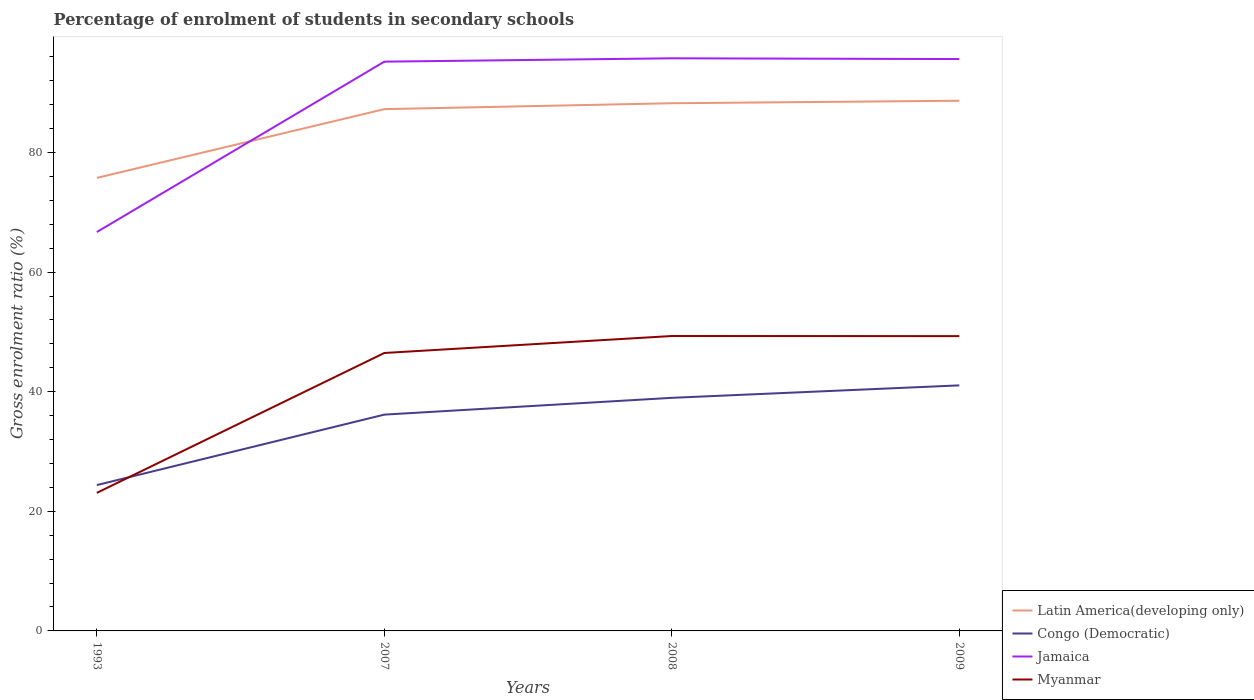How many different coloured lines are there?
Offer a terse response. 4. Does the line corresponding to Latin America(developing only) intersect with the line corresponding to Jamaica?
Offer a very short reply. Yes. Is the number of lines equal to the number of legend labels?
Keep it short and to the point. Yes. Across all years, what is the maximum percentage of students enrolled in secondary schools in Myanmar?
Offer a terse response. 23.09. What is the total percentage of students enrolled in secondary schools in Myanmar in the graph?
Ensure brevity in your answer.  -26.21. What is the difference between the highest and the second highest percentage of students enrolled in secondary schools in Jamaica?
Provide a short and direct response. 29.05. How many years are there in the graph?
Give a very brief answer. 4. Are the values on the major ticks of Y-axis written in scientific E-notation?
Your answer should be very brief. No. Does the graph contain any zero values?
Your answer should be very brief. No. Where does the legend appear in the graph?
Keep it short and to the point. Bottom right. What is the title of the graph?
Provide a succinct answer. Percentage of enrolment of students in secondary schools. What is the label or title of the Y-axis?
Ensure brevity in your answer.  Gross enrolment ratio (%). What is the Gross enrolment ratio (%) in Latin America(developing only) in 1993?
Provide a short and direct response. 75.75. What is the Gross enrolment ratio (%) of Congo (Democratic) in 1993?
Your answer should be very brief. 24.39. What is the Gross enrolment ratio (%) of Jamaica in 1993?
Give a very brief answer. 66.69. What is the Gross enrolment ratio (%) in Myanmar in 1993?
Your answer should be very brief. 23.09. What is the Gross enrolment ratio (%) of Latin America(developing only) in 2007?
Ensure brevity in your answer.  87.24. What is the Gross enrolment ratio (%) in Congo (Democratic) in 2007?
Offer a very short reply. 36.17. What is the Gross enrolment ratio (%) of Jamaica in 2007?
Provide a short and direct response. 95.18. What is the Gross enrolment ratio (%) of Myanmar in 2007?
Provide a short and direct response. 46.47. What is the Gross enrolment ratio (%) in Latin America(developing only) in 2008?
Your response must be concise. 88.23. What is the Gross enrolment ratio (%) in Congo (Democratic) in 2008?
Your response must be concise. 38.97. What is the Gross enrolment ratio (%) of Jamaica in 2008?
Your answer should be compact. 95.75. What is the Gross enrolment ratio (%) in Myanmar in 2008?
Provide a short and direct response. 49.31. What is the Gross enrolment ratio (%) in Latin America(developing only) in 2009?
Give a very brief answer. 88.65. What is the Gross enrolment ratio (%) in Congo (Democratic) in 2009?
Your answer should be very brief. 41.06. What is the Gross enrolment ratio (%) in Jamaica in 2009?
Provide a short and direct response. 95.62. What is the Gross enrolment ratio (%) in Myanmar in 2009?
Your response must be concise. 49.29. Across all years, what is the maximum Gross enrolment ratio (%) of Latin America(developing only)?
Ensure brevity in your answer.  88.65. Across all years, what is the maximum Gross enrolment ratio (%) in Congo (Democratic)?
Provide a succinct answer. 41.06. Across all years, what is the maximum Gross enrolment ratio (%) in Jamaica?
Make the answer very short. 95.75. Across all years, what is the maximum Gross enrolment ratio (%) of Myanmar?
Make the answer very short. 49.31. Across all years, what is the minimum Gross enrolment ratio (%) of Latin America(developing only)?
Your answer should be compact. 75.75. Across all years, what is the minimum Gross enrolment ratio (%) of Congo (Democratic)?
Make the answer very short. 24.39. Across all years, what is the minimum Gross enrolment ratio (%) in Jamaica?
Your answer should be compact. 66.69. Across all years, what is the minimum Gross enrolment ratio (%) of Myanmar?
Offer a very short reply. 23.09. What is the total Gross enrolment ratio (%) in Latin America(developing only) in the graph?
Keep it short and to the point. 339.88. What is the total Gross enrolment ratio (%) of Congo (Democratic) in the graph?
Give a very brief answer. 140.59. What is the total Gross enrolment ratio (%) in Jamaica in the graph?
Offer a terse response. 353.24. What is the total Gross enrolment ratio (%) in Myanmar in the graph?
Make the answer very short. 168.16. What is the difference between the Gross enrolment ratio (%) of Latin America(developing only) in 1993 and that in 2007?
Provide a short and direct response. -11.49. What is the difference between the Gross enrolment ratio (%) in Congo (Democratic) in 1993 and that in 2007?
Give a very brief answer. -11.78. What is the difference between the Gross enrolment ratio (%) in Jamaica in 1993 and that in 2007?
Your answer should be compact. -28.49. What is the difference between the Gross enrolment ratio (%) in Myanmar in 1993 and that in 2007?
Make the answer very short. -23.39. What is the difference between the Gross enrolment ratio (%) of Latin America(developing only) in 1993 and that in 2008?
Offer a terse response. -12.48. What is the difference between the Gross enrolment ratio (%) in Congo (Democratic) in 1993 and that in 2008?
Offer a very short reply. -14.59. What is the difference between the Gross enrolment ratio (%) in Jamaica in 1993 and that in 2008?
Your response must be concise. -29.05. What is the difference between the Gross enrolment ratio (%) in Myanmar in 1993 and that in 2008?
Offer a terse response. -26.22. What is the difference between the Gross enrolment ratio (%) of Latin America(developing only) in 1993 and that in 2009?
Give a very brief answer. -12.9. What is the difference between the Gross enrolment ratio (%) of Congo (Democratic) in 1993 and that in 2009?
Provide a short and direct response. -16.67. What is the difference between the Gross enrolment ratio (%) in Jamaica in 1993 and that in 2009?
Make the answer very short. -28.92. What is the difference between the Gross enrolment ratio (%) of Myanmar in 1993 and that in 2009?
Provide a succinct answer. -26.21. What is the difference between the Gross enrolment ratio (%) of Latin America(developing only) in 2007 and that in 2008?
Offer a very short reply. -0.99. What is the difference between the Gross enrolment ratio (%) in Congo (Democratic) in 2007 and that in 2008?
Keep it short and to the point. -2.81. What is the difference between the Gross enrolment ratio (%) of Jamaica in 2007 and that in 2008?
Your answer should be very brief. -0.56. What is the difference between the Gross enrolment ratio (%) of Myanmar in 2007 and that in 2008?
Provide a succinct answer. -2.84. What is the difference between the Gross enrolment ratio (%) in Latin America(developing only) in 2007 and that in 2009?
Your answer should be compact. -1.4. What is the difference between the Gross enrolment ratio (%) in Congo (Democratic) in 2007 and that in 2009?
Ensure brevity in your answer.  -4.89. What is the difference between the Gross enrolment ratio (%) of Jamaica in 2007 and that in 2009?
Your answer should be compact. -0.43. What is the difference between the Gross enrolment ratio (%) in Myanmar in 2007 and that in 2009?
Provide a succinct answer. -2.82. What is the difference between the Gross enrolment ratio (%) in Latin America(developing only) in 2008 and that in 2009?
Your answer should be compact. -0.42. What is the difference between the Gross enrolment ratio (%) in Congo (Democratic) in 2008 and that in 2009?
Offer a terse response. -2.08. What is the difference between the Gross enrolment ratio (%) of Jamaica in 2008 and that in 2009?
Make the answer very short. 0.13. What is the difference between the Gross enrolment ratio (%) of Myanmar in 2008 and that in 2009?
Keep it short and to the point. 0.02. What is the difference between the Gross enrolment ratio (%) of Latin America(developing only) in 1993 and the Gross enrolment ratio (%) of Congo (Democratic) in 2007?
Make the answer very short. 39.58. What is the difference between the Gross enrolment ratio (%) in Latin America(developing only) in 1993 and the Gross enrolment ratio (%) in Jamaica in 2007?
Offer a very short reply. -19.43. What is the difference between the Gross enrolment ratio (%) of Latin America(developing only) in 1993 and the Gross enrolment ratio (%) of Myanmar in 2007?
Make the answer very short. 29.28. What is the difference between the Gross enrolment ratio (%) in Congo (Democratic) in 1993 and the Gross enrolment ratio (%) in Jamaica in 2007?
Keep it short and to the point. -70.8. What is the difference between the Gross enrolment ratio (%) in Congo (Democratic) in 1993 and the Gross enrolment ratio (%) in Myanmar in 2007?
Provide a short and direct response. -22.09. What is the difference between the Gross enrolment ratio (%) of Jamaica in 1993 and the Gross enrolment ratio (%) of Myanmar in 2007?
Offer a very short reply. 20.22. What is the difference between the Gross enrolment ratio (%) in Latin America(developing only) in 1993 and the Gross enrolment ratio (%) in Congo (Democratic) in 2008?
Give a very brief answer. 36.78. What is the difference between the Gross enrolment ratio (%) in Latin America(developing only) in 1993 and the Gross enrolment ratio (%) in Jamaica in 2008?
Your answer should be compact. -19.99. What is the difference between the Gross enrolment ratio (%) of Latin America(developing only) in 1993 and the Gross enrolment ratio (%) of Myanmar in 2008?
Ensure brevity in your answer.  26.44. What is the difference between the Gross enrolment ratio (%) in Congo (Democratic) in 1993 and the Gross enrolment ratio (%) in Jamaica in 2008?
Keep it short and to the point. -71.36. What is the difference between the Gross enrolment ratio (%) of Congo (Democratic) in 1993 and the Gross enrolment ratio (%) of Myanmar in 2008?
Your answer should be compact. -24.92. What is the difference between the Gross enrolment ratio (%) of Jamaica in 1993 and the Gross enrolment ratio (%) of Myanmar in 2008?
Give a very brief answer. 17.38. What is the difference between the Gross enrolment ratio (%) of Latin America(developing only) in 1993 and the Gross enrolment ratio (%) of Congo (Democratic) in 2009?
Your response must be concise. 34.69. What is the difference between the Gross enrolment ratio (%) in Latin America(developing only) in 1993 and the Gross enrolment ratio (%) in Jamaica in 2009?
Ensure brevity in your answer.  -19.87. What is the difference between the Gross enrolment ratio (%) in Latin America(developing only) in 1993 and the Gross enrolment ratio (%) in Myanmar in 2009?
Your answer should be very brief. 26.46. What is the difference between the Gross enrolment ratio (%) in Congo (Democratic) in 1993 and the Gross enrolment ratio (%) in Jamaica in 2009?
Your answer should be compact. -71.23. What is the difference between the Gross enrolment ratio (%) in Congo (Democratic) in 1993 and the Gross enrolment ratio (%) in Myanmar in 2009?
Keep it short and to the point. -24.91. What is the difference between the Gross enrolment ratio (%) of Jamaica in 1993 and the Gross enrolment ratio (%) of Myanmar in 2009?
Make the answer very short. 17.4. What is the difference between the Gross enrolment ratio (%) of Latin America(developing only) in 2007 and the Gross enrolment ratio (%) of Congo (Democratic) in 2008?
Your response must be concise. 48.27. What is the difference between the Gross enrolment ratio (%) in Latin America(developing only) in 2007 and the Gross enrolment ratio (%) in Jamaica in 2008?
Offer a terse response. -8.5. What is the difference between the Gross enrolment ratio (%) in Latin America(developing only) in 2007 and the Gross enrolment ratio (%) in Myanmar in 2008?
Your response must be concise. 37.93. What is the difference between the Gross enrolment ratio (%) of Congo (Democratic) in 2007 and the Gross enrolment ratio (%) of Jamaica in 2008?
Keep it short and to the point. -59.58. What is the difference between the Gross enrolment ratio (%) of Congo (Democratic) in 2007 and the Gross enrolment ratio (%) of Myanmar in 2008?
Make the answer very short. -13.14. What is the difference between the Gross enrolment ratio (%) of Jamaica in 2007 and the Gross enrolment ratio (%) of Myanmar in 2008?
Offer a terse response. 45.87. What is the difference between the Gross enrolment ratio (%) in Latin America(developing only) in 2007 and the Gross enrolment ratio (%) in Congo (Democratic) in 2009?
Your answer should be compact. 46.19. What is the difference between the Gross enrolment ratio (%) of Latin America(developing only) in 2007 and the Gross enrolment ratio (%) of Jamaica in 2009?
Give a very brief answer. -8.37. What is the difference between the Gross enrolment ratio (%) of Latin America(developing only) in 2007 and the Gross enrolment ratio (%) of Myanmar in 2009?
Your answer should be very brief. 37.95. What is the difference between the Gross enrolment ratio (%) in Congo (Democratic) in 2007 and the Gross enrolment ratio (%) in Jamaica in 2009?
Ensure brevity in your answer.  -59.45. What is the difference between the Gross enrolment ratio (%) in Congo (Democratic) in 2007 and the Gross enrolment ratio (%) in Myanmar in 2009?
Ensure brevity in your answer.  -13.12. What is the difference between the Gross enrolment ratio (%) of Jamaica in 2007 and the Gross enrolment ratio (%) of Myanmar in 2009?
Offer a terse response. 45.89. What is the difference between the Gross enrolment ratio (%) of Latin America(developing only) in 2008 and the Gross enrolment ratio (%) of Congo (Democratic) in 2009?
Your answer should be compact. 47.17. What is the difference between the Gross enrolment ratio (%) in Latin America(developing only) in 2008 and the Gross enrolment ratio (%) in Jamaica in 2009?
Offer a very short reply. -7.39. What is the difference between the Gross enrolment ratio (%) in Latin America(developing only) in 2008 and the Gross enrolment ratio (%) in Myanmar in 2009?
Give a very brief answer. 38.94. What is the difference between the Gross enrolment ratio (%) of Congo (Democratic) in 2008 and the Gross enrolment ratio (%) of Jamaica in 2009?
Your answer should be compact. -56.65. What is the difference between the Gross enrolment ratio (%) of Congo (Democratic) in 2008 and the Gross enrolment ratio (%) of Myanmar in 2009?
Offer a very short reply. -10.32. What is the difference between the Gross enrolment ratio (%) in Jamaica in 2008 and the Gross enrolment ratio (%) in Myanmar in 2009?
Give a very brief answer. 46.45. What is the average Gross enrolment ratio (%) of Latin America(developing only) per year?
Make the answer very short. 84.97. What is the average Gross enrolment ratio (%) in Congo (Democratic) per year?
Keep it short and to the point. 35.15. What is the average Gross enrolment ratio (%) in Jamaica per year?
Provide a short and direct response. 88.31. What is the average Gross enrolment ratio (%) in Myanmar per year?
Offer a very short reply. 42.04. In the year 1993, what is the difference between the Gross enrolment ratio (%) in Latin America(developing only) and Gross enrolment ratio (%) in Congo (Democratic)?
Give a very brief answer. 51.36. In the year 1993, what is the difference between the Gross enrolment ratio (%) of Latin America(developing only) and Gross enrolment ratio (%) of Jamaica?
Give a very brief answer. 9.06. In the year 1993, what is the difference between the Gross enrolment ratio (%) in Latin America(developing only) and Gross enrolment ratio (%) in Myanmar?
Give a very brief answer. 52.66. In the year 1993, what is the difference between the Gross enrolment ratio (%) in Congo (Democratic) and Gross enrolment ratio (%) in Jamaica?
Provide a short and direct response. -42.31. In the year 1993, what is the difference between the Gross enrolment ratio (%) in Congo (Democratic) and Gross enrolment ratio (%) in Myanmar?
Keep it short and to the point. 1.3. In the year 1993, what is the difference between the Gross enrolment ratio (%) of Jamaica and Gross enrolment ratio (%) of Myanmar?
Ensure brevity in your answer.  43.61. In the year 2007, what is the difference between the Gross enrolment ratio (%) of Latin America(developing only) and Gross enrolment ratio (%) of Congo (Democratic)?
Provide a succinct answer. 51.08. In the year 2007, what is the difference between the Gross enrolment ratio (%) of Latin America(developing only) and Gross enrolment ratio (%) of Jamaica?
Keep it short and to the point. -7.94. In the year 2007, what is the difference between the Gross enrolment ratio (%) of Latin America(developing only) and Gross enrolment ratio (%) of Myanmar?
Your answer should be compact. 40.77. In the year 2007, what is the difference between the Gross enrolment ratio (%) of Congo (Democratic) and Gross enrolment ratio (%) of Jamaica?
Your response must be concise. -59.02. In the year 2007, what is the difference between the Gross enrolment ratio (%) of Congo (Democratic) and Gross enrolment ratio (%) of Myanmar?
Offer a very short reply. -10.31. In the year 2007, what is the difference between the Gross enrolment ratio (%) of Jamaica and Gross enrolment ratio (%) of Myanmar?
Your answer should be compact. 48.71. In the year 2008, what is the difference between the Gross enrolment ratio (%) in Latin America(developing only) and Gross enrolment ratio (%) in Congo (Democratic)?
Your answer should be compact. 49.26. In the year 2008, what is the difference between the Gross enrolment ratio (%) of Latin America(developing only) and Gross enrolment ratio (%) of Jamaica?
Make the answer very short. -7.51. In the year 2008, what is the difference between the Gross enrolment ratio (%) in Latin America(developing only) and Gross enrolment ratio (%) in Myanmar?
Keep it short and to the point. 38.92. In the year 2008, what is the difference between the Gross enrolment ratio (%) of Congo (Democratic) and Gross enrolment ratio (%) of Jamaica?
Keep it short and to the point. -56.77. In the year 2008, what is the difference between the Gross enrolment ratio (%) of Congo (Democratic) and Gross enrolment ratio (%) of Myanmar?
Offer a very short reply. -10.34. In the year 2008, what is the difference between the Gross enrolment ratio (%) of Jamaica and Gross enrolment ratio (%) of Myanmar?
Your answer should be compact. 46.44. In the year 2009, what is the difference between the Gross enrolment ratio (%) in Latin America(developing only) and Gross enrolment ratio (%) in Congo (Democratic)?
Offer a terse response. 47.59. In the year 2009, what is the difference between the Gross enrolment ratio (%) in Latin America(developing only) and Gross enrolment ratio (%) in Jamaica?
Your answer should be compact. -6.97. In the year 2009, what is the difference between the Gross enrolment ratio (%) in Latin America(developing only) and Gross enrolment ratio (%) in Myanmar?
Provide a succinct answer. 39.36. In the year 2009, what is the difference between the Gross enrolment ratio (%) in Congo (Democratic) and Gross enrolment ratio (%) in Jamaica?
Ensure brevity in your answer.  -54.56. In the year 2009, what is the difference between the Gross enrolment ratio (%) in Congo (Democratic) and Gross enrolment ratio (%) in Myanmar?
Your answer should be very brief. -8.23. In the year 2009, what is the difference between the Gross enrolment ratio (%) in Jamaica and Gross enrolment ratio (%) in Myanmar?
Your answer should be compact. 46.33. What is the ratio of the Gross enrolment ratio (%) of Latin America(developing only) in 1993 to that in 2007?
Provide a short and direct response. 0.87. What is the ratio of the Gross enrolment ratio (%) of Congo (Democratic) in 1993 to that in 2007?
Ensure brevity in your answer.  0.67. What is the ratio of the Gross enrolment ratio (%) in Jamaica in 1993 to that in 2007?
Your answer should be very brief. 0.7. What is the ratio of the Gross enrolment ratio (%) in Myanmar in 1993 to that in 2007?
Make the answer very short. 0.5. What is the ratio of the Gross enrolment ratio (%) in Latin America(developing only) in 1993 to that in 2008?
Keep it short and to the point. 0.86. What is the ratio of the Gross enrolment ratio (%) in Congo (Democratic) in 1993 to that in 2008?
Your response must be concise. 0.63. What is the ratio of the Gross enrolment ratio (%) of Jamaica in 1993 to that in 2008?
Your answer should be compact. 0.7. What is the ratio of the Gross enrolment ratio (%) of Myanmar in 1993 to that in 2008?
Your answer should be compact. 0.47. What is the ratio of the Gross enrolment ratio (%) in Latin America(developing only) in 1993 to that in 2009?
Give a very brief answer. 0.85. What is the ratio of the Gross enrolment ratio (%) in Congo (Democratic) in 1993 to that in 2009?
Keep it short and to the point. 0.59. What is the ratio of the Gross enrolment ratio (%) of Jamaica in 1993 to that in 2009?
Make the answer very short. 0.7. What is the ratio of the Gross enrolment ratio (%) of Myanmar in 1993 to that in 2009?
Your answer should be very brief. 0.47. What is the ratio of the Gross enrolment ratio (%) of Congo (Democratic) in 2007 to that in 2008?
Provide a succinct answer. 0.93. What is the ratio of the Gross enrolment ratio (%) of Jamaica in 2007 to that in 2008?
Make the answer very short. 0.99. What is the ratio of the Gross enrolment ratio (%) of Myanmar in 2007 to that in 2008?
Offer a very short reply. 0.94. What is the ratio of the Gross enrolment ratio (%) of Latin America(developing only) in 2007 to that in 2009?
Give a very brief answer. 0.98. What is the ratio of the Gross enrolment ratio (%) in Congo (Democratic) in 2007 to that in 2009?
Offer a very short reply. 0.88. What is the ratio of the Gross enrolment ratio (%) in Myanmar in 2007 to that in 2009?
Provide a succinct answer. 0.94. What is the ratio of the Gross enrolment ratio (%) in Congo (Democratic) in 2008 to that in 2009?
Offer a very short reply. 0.95. What is the ratio of the Gross enrolment ratio (%) in Jamaica in 2008 to that in 2009?
Your response must be concise. 1. What is the difference between the highest and the second highest Gross enrolment ratio (%) in Latin America(developing only)?
Offer a terse response. 0.42. What is the difference between the highest and the second highest Gross enrolment ratio (%) in Congo (Democratic)?
Offer a terse response. 2.08. What is the difference between the highest and the second highest Gross enrolment ratio (%) of Jamaica?
Offer a very short reply. 0.13. What is the difference between the highest and the second highest Gross enrolment ratio (%) of Myanmar?
Provide a short and direct response. 0.02. What is the difference between the highest and the lowest Gross enrolment ratio (%) of Latin America(developing only)?
Your answer should be very brief. 12.9. What is the difference between the highest and the lowest Gross enrolment ratio (%) in Congo (Democratic)?
Offer a very short reply. 16.67. What is the difference between the highest and the lowest Gross enrolment ratio (%) of Jamaica?
Provide a short and direct response. 29.05. What is the difference between the highest and the lowest Gross enrolment ratio (%) of Myanmar?
Offer a very short reply. 26.22. 